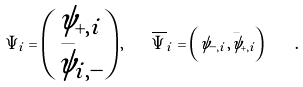Convert formula to latex. <formula><loc_0><loc_0><loc_500><loc_500>\Psi _ { i } = \begin{pmatrix} \psi _ { + , i } \\ \bar { \psi } _ { i , - } \end{pmatrix} , \quad \overline { \Psi } _ { i } = \left ( \psi _ { - , i } , \bar { \psi } _ { + , i } \right ) \quad .</formula> 